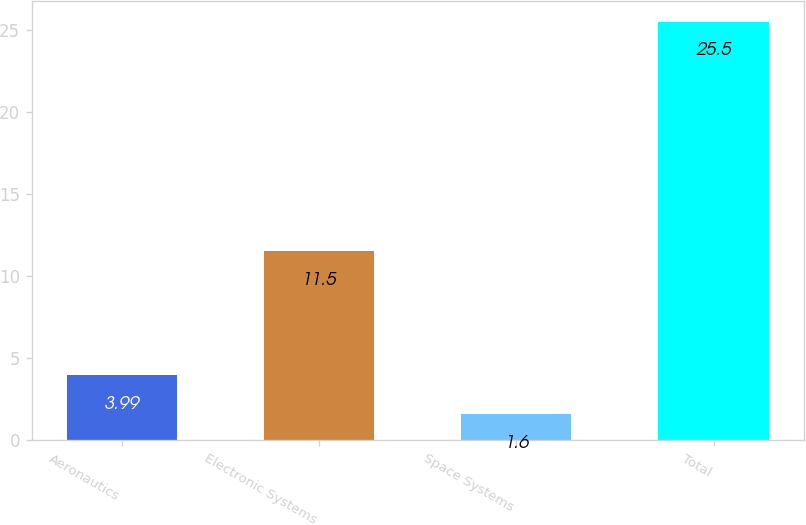<chart> <loc_0><loc_0><loc_500><loc_500><bar_chart><fcel>Aeronautics<fcel>Electronic Systems<fcel>Space Systems<fcel>Total<nl><fcel>3.99<fcel>11.5<fcel>1.6<fcel>25.5<nl></chart> 